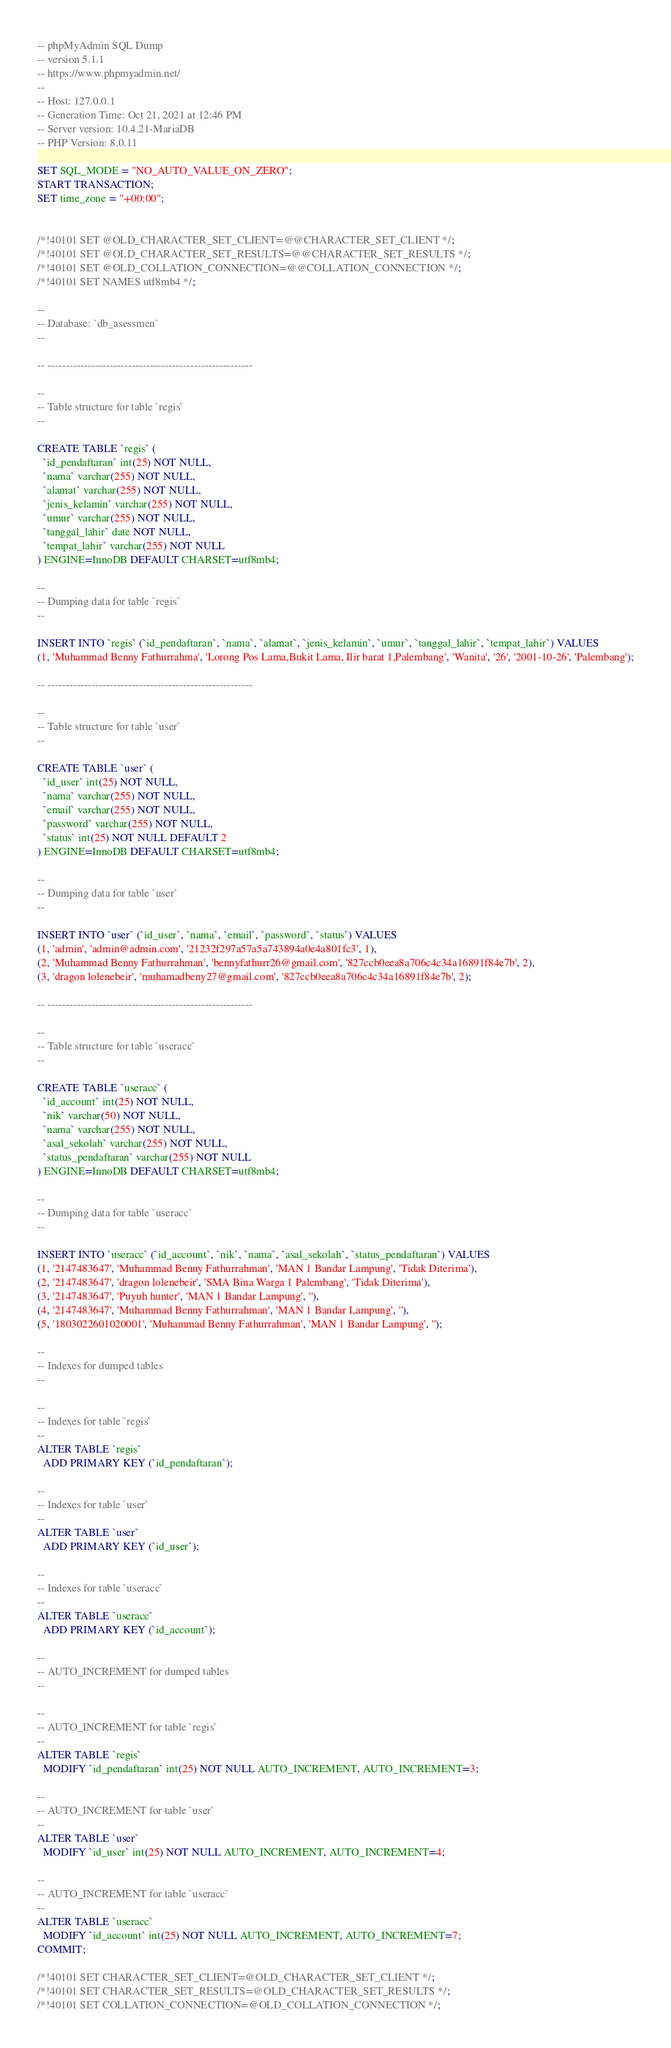<code> <loc_0><loc_0><loc_500><loc_500><_SQL_>-- phpMyAdmin SQL Dump
-- version 5.1.1
-- https://www.phpmyadmin.net/
--
-- Host: 127.0.0.1
-- Generation Time: Oct 21, 2021 at 12:46 PM
-- Server version: 10.4.21-MariaDB
-- PHP Version: 8.0.11

SET SQL_MODE = "NO_AUTO_VALUE_ON_ZERO";
START TRANSACTION;
SET time_zone = "+00:00";


/*!40101 SET @OLD_CHARACTER_SET_CLIENT=@@CHARACTER_SET_CLIENT */;
/*!40101 SET @OLD_CHARACTER_SET_RESULTS=@@CHARACTER_SET_RESULTS */;
/*!40101 SET @OLD_COLLATION_CONNECTION=@@COLLATION_CONNECTION */;
/*!40101 SET NAMES utf8mb4 */;

--
-- Database: `db_asessmen`
--

-- --------------------------------------------------------

--
-- Table structure for table `regis`
--

CREATE TABLE `regis` (
  `id_pendaftaran` int(25) NOT NULL,
  `nama` varchar(255) NOT NULL,
  `alamat` varchar(255) NOT NULL,
  `jenis_kelamin` varchar(255) NOT NULL,
  `umur` varchar(255) NOT NULL,
  `tanggal_lahir` date NOT NULL,
  `tempat_lahir` varchar(255) NOT NULL
) ENGINE=InnoDB DEFAULT CHARSET=utf8mb4;

--
-- Dumping data for table `regis`
--

INSERT INTO `regis` (`id_pendaftaran`, `nama`, `alamat`, `jenis_kelamin`, `umur`, `tanggal_lahir`, `tempat_lahir`) VALUES
(1, 'Muhammad Benny Fathurrahma', 'Lorong Pos Lama,Bukit Lama, Ilir barat 1,Palembang', 'Wanita', '26', '2001-10-26', 'Palembang');

-- --------------------------------------------------------

--
-- Table structure for table `user`
--

CREATE TABLE `user` (
  `id_user` int(25) NOT NULL,
  `nama` varchar(255) NOT NULL,
  `email` varchar(255) NOT NULL,
  `password` varchar(255) NOT NULL,
  `status` int(25) NOT NULL DEFAULT 2
) ENGINE=InnoDB DEFAULT CHARSET=utf8mb4;

--
-- Dumping data for table `user`
--

INSERT INTO `user` (`id_user`, `nama`, `email`, `password`, `status`) VALUES
(1, 'admin', 'admin@admin.com', '21232f297a57a5a743894a0e4a801fc3', 1),
(2, 'Muhammad Benny Fathurrahman', 'bennyfathurr26@gmail.com', '827ccb0eea8a706c4c34a16891f84e7b', 2),
(3, 'dragon lolenebeir', 'muhamadbeny27@gmail.com', '827ccb0eea8a706c4c34a16891f84e7b', 2);

-- --------------------------------------------------------

--
-- Table structure for table `useracc`
--

CREATE TABLE `useracc` (
  `id_account` int(25) NOT NULL,
  `nik` varchar(50) NOT NULL,
  `nama` varchar(255) NOT NULL,
  `asal_sekolah` varchar(255) NOT NULL,
  `status_pendaftaran` varchar(255) NOT NULL
) ENGINE=InnoDB DEFAULT CHARSET=utf8mb4;

--
-- Dumping data for table `useracc`
--

INSERT INTO `useracc` (`id_account`, `nik`, `nama`, `asal_sekolah`, `status_pendaftaran`) VALUES
(1, '2147483647', 'Muhammad Benny Fathurrahman', 'MAN 1 Bandar Lampung', 'Tidak Diterima'),
(2, '2147483647', 'dragon lolenebeir', 'SMA Bina Warga 1 Palembang', 'Tidak Diterima'),
(3, '2147483647', 'Puyuh hunter', 'MAN 1 Bandar Lampung', ''),
(4, '2147483647', 'Muhammad Benny Fathurrahman', 'MAN 1 Bandar Lampung', ''),
(5, '1803022601020001', 'Muhammad Benny Fathurrahman', 'MAN 1 Bandar Lampung', '');

--
-- Indexes for dumped tables
--

--
-- Indexes for table `regis`
--
ALTER TABLE `regis`
  ADD PRIMARY KEY (`id_pendaftaran`);

--
-- Indexes for table `user`
--
ALTER TABLE `user`
  ADD PRIMARY KEY (`id_user`);

--
-- Indexes for table `useracc`
--
ALTER TABLE `useracc`
  ADD PRIMARY KEY (`id_account`);

--
-- AUTO_INCREMENT for dumped tables
--

--
-- AUTO_INCREMENT for table `regis`
--
ALTER TABLE `regis`
  MODIFY `id_pendaftaran` int(25) NOT NULL AUTO_INCREMENT, AUTO_INCREMENT=3;

--
-- AUTO_INCREMENT for table `user`
--
ALTER TABLE `user`
  MODIFY `id_user` int(25) NOT NULL AUTO_INCREMENT, AUTO_INCREMENT=4;

--
-- AUTO_INCREMENT for table `useracc`
--
ALTER TABLE `useracc`
  MODIFY `id_account` int(25) NOT NULL AUTO_INCREMENT, AUTO_INCREMENT=7;
COMMIT;

/*!40101 SET CHARACTER_SET_CLIENT=@OLD_CHARACTER_SET_CLIENT */;
/*!40101 SET CHARACTER_SET_RESULTS=@OLD_CHARACTER_SET_RESULTS */;
/*!40101 SET COLLATION_CONNECTION=@OLD_COLLATION_CONNECTION */;
</code> 